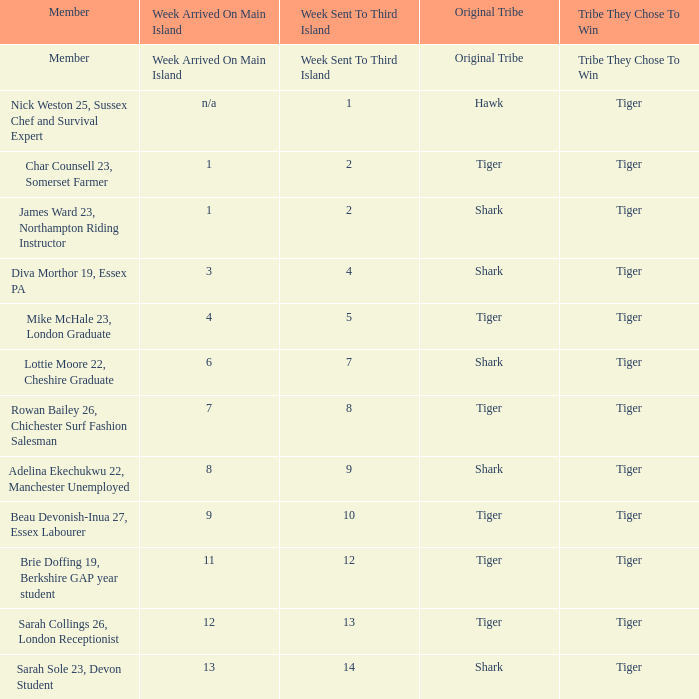During week 1, who was sent to island number three? Nick Weston 25, Sussex Chef and Survival Expert. 